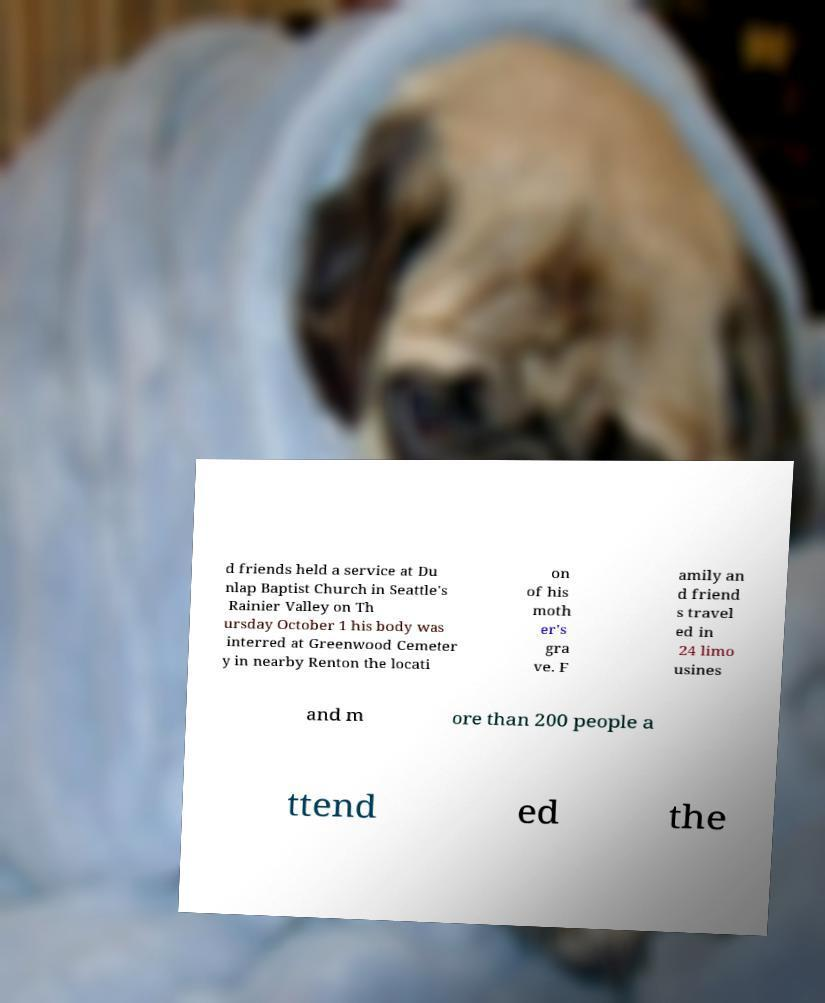Can you read and provide the text displayed in the image?This photo seems to have some interesting text. Can you extract and type it out for me? d friends held a service at Du nlap Baptist Church in Seattle's Rainier Valley on Th ursday October 1 his body was interred at Greenwood Cemeter y in nearby Renton the locati on of his moth er's gra ve. F amily an d friend s travel ed in 24 limo usines and m ore than 200 people a ttend ed the 